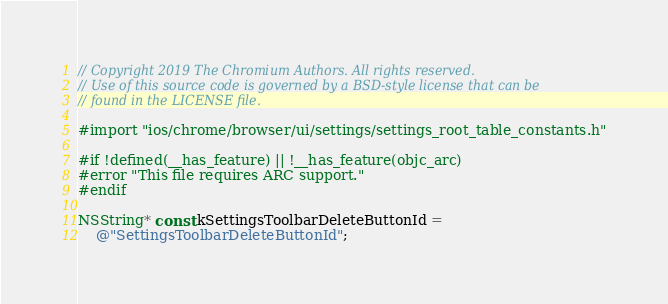Convert code to text. <code><loc_0><loc_0><loc_500><loc_500><_ObjectiveC_>// Copyright 2019 The Chromium Authors. All rights reserved.
// Use of this source code is governed by a BSD-style license that can be
// found in the LICENSE file.

#import "ios/chrome/browser/ui/settings/settings_root_table_constants.h"

#if !defined(__has_feature) || !__has_feature(objc_arc)
#error "This file requires ARC support."
#endif

NSString* const kSettingsToolbarDeleteButtonId =
    @"SettingsToolbarDeleteButtonId";
</code> 